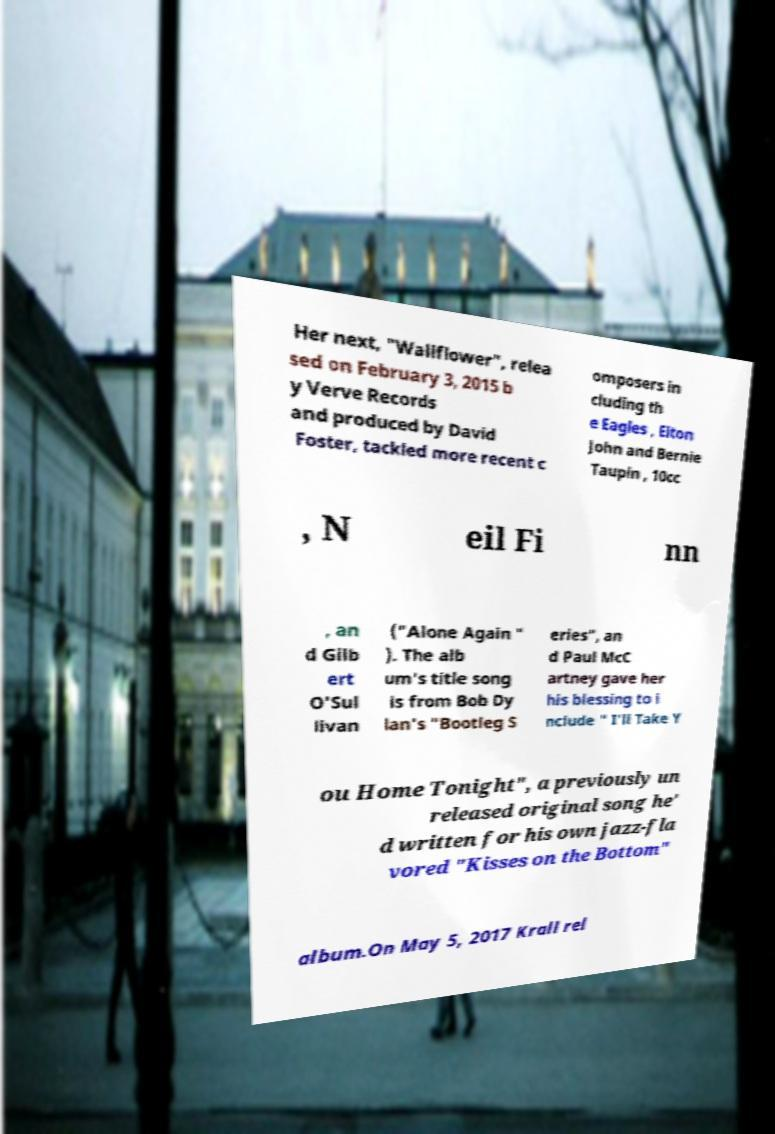Can you accurately transcribe the text from the provided image for me? Her next, "Wallflower", relea sed on February 3, 2015 b y Verve Records and produced by David Foster, tackled more recent c omposers in cluding th e Eagles , Elton John and Bernie Taupin , 10cc , N eil Fi nn , an d Gilb ert O'Sul livan ("Alone Again " ). The alb um's title song is from Bob Dy lan's "Bootleg S eries", an d Paul McC artney gave her his blessing to i nclude " I'll Take Y ou Home Tonight", a previously un released original song he' d written for his own jazz-fla vored "Kisses on the Bottom" album.On May 5, 2017 Krall rel 